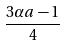<formula> <loc_0><loc_0><loc_500><loc_500>\frac { 3 \alpha a - 1 } { 4 }</formula> 